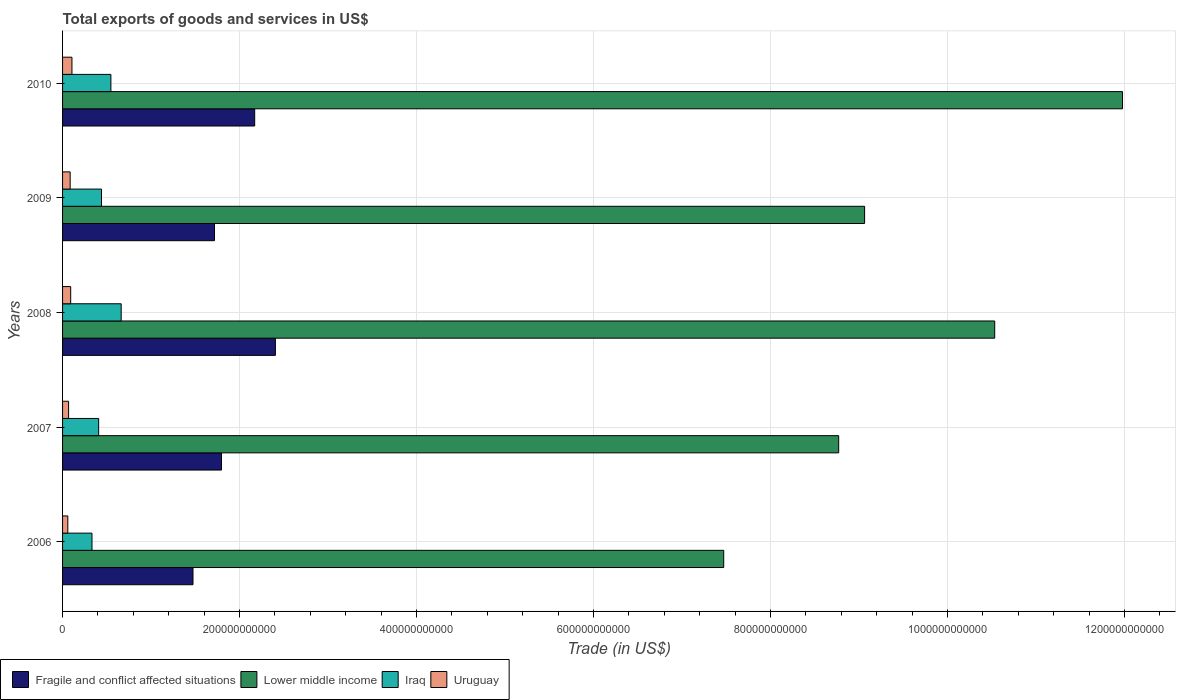How many bars are there on the 1st tick from the bottom?
Provide a short and direct response. 4. What is the label of the 4th group of bars from the top?
Give a very brief answer. 2007. What is the total exports of goods and services in Fragile and conflict affected situations in 2008?
Provide a short and direct response. 2.41e+11. Across all years, what is the maximum total exports of goods and services in Lower middle income?
Provide a short and direct response. 1.20e+12. Across all years, what is the minimum total exports of goods and services in Lower middle income?
Provide a short and direct response. 7.47e+11. In which year was the total exports of goods and services in Iraq maximum?
Offer a very short reply. 2008. What is the total total exports of goods and services in Lower middle income in the graph?
Give a very brief answer. 4.78e+12. What is the difference between the total exports of goods and services in Lower middle income in 2008 and that in 2009?
Offer a very short reply. 1.47e+11. What is the difference between the total exports of goods and services in Fragile and conflict affected situations in 2006 and the total exports of goods and services in Uruguay in 2008?
Provide a short and direct response. 1.38e+11. What is the average total exports of goods and services in Fragile and conflict affected situations per year?
Provide a short and direct response. 1.91e+11. In the year 2009, what is the difference between the total exports of goods and services in Lower middle income and total exports of goods and services in Uruguay?
Make the answer very short. 8.98e+11. In how many years, is the total exports of goods and services in Fragile and conflict affected situations greater than 400000000000 US$?
Provide a succinct answer. 0. What is the ratio of the total exports of goods and services in Lower middle income in 2008 to that in 2009?
Keep it short and to the point. 1.16. Is the total exports of goods and services in Lower middle income in 2008 less than that in 2010?
Your answer should be compact. Yes. What is the difference between the highest and the second highest total exports of goods and services in Lower middle income?
Ensure brevity in your answer.  1.44e+11. What is the difference between the highest and the lowest total exports of goods and services in Iraq?
Give a very brief answer. 3.30e+1. In how many years, is the total exports of goods and services in Uruguay greater than the average total exports of goods and services in Uruguay taken over all years?
Provide a succinct answer. 3. Is it the case that in every year, the sum of the total exports of goods and services in Iraq and total exports of goods and services in Uruguay is greater than the sum of total exports of goods and services in Lower middle income and total exports of goods and services in Fragile and conflict affected situations?
Offer a terse response. Yes. What does the 3rd bar from the top in 2008 represents?
Give a very brief answer. Lower middle income. What does the 1st bar from the bottom in 2008 represents?
Offer a very short reply. Fragile and conflict affected situations. Is it the case that in every year, the sum of the total exports of goods and services in Iraq and total exports of goods and services in Lower middle income is greater than the total exports of goods and services in Uruguay?
Offer a terse response. Yes. How many bars are there?
Give a very brief answer. 20. How many years are there in the graph?
Keep it short and to the point. 5. What is the difference between two consecutive major ticks on the X-axis?
Your answer should be very brief. 2.00e+11. Are the values on the major ticks of X-axis written in scientific E-notation?
Your answer should be compact. No. Does the graph contain any zero values?
Make the answer very short. No. Does the graph contain grids?
Make the answer very short. Yes. How many legend labels are there?
Your answer should be very brief. 4. What is the title of the graph?
Give a very brief answer. Total exports of goods and services in US$. Does "Mauritania" appear as one of the legend labels in the graph?
Your answer should be compact. No. What is the label or title of the X-axis?
Keep it short and to the point. Trade (in US$). What is the label or title of the Y-axis?
Your response must be concise. Years. What is the Trade (in US$) in Fragile and conflict affected situations in 2006?
Offer a terse response. 1.47e+11. What is the Trade (in US$) in Lower middle income in 2006?
Your response must be concise. 7.47e+11. What is the Trade (in US$) of Iraq in 2006?
Provide a succinct answer. 3.32e+1. What is the Trade (in US$) in Uruguay in 2006?
Offer a terse response. 5.93e+09. What is the Trade (in US$) of Fragile and conflict affected situations in 2007?
Make the answer very short. 1.80e+11. What is the Trade (in US$) in Lower middle income in 2007?
Offer a terse response. 8.77e+11. What is the Trade (in US$) of Iraq in 2007?
Your answer should be compact. 4.08e+1. What is the Trade (in US$) in Uruguay in 2007?
Your answer should be compact. 6.81e+09. What is the Trade (in US$) in Fragile and conflict affected situations in 2008?
Your answer should be compact. 2.41e+11. What is the Trade (in US$) of Lower middle income in 2008?
Make the answer very short. 1.05e+12. What is the Trade (in US$) in Iraq in 2008?
Your response must be concise. 6.62e+1. What is the Trade (in US$) in Uruguay in 2008?
Make the answer very short. 9.17e+09. What is the Trade (in US$) of Fragile and conflict affected situations in 2009?
Give a very brief answer. 1.72e+11. What is the Trade (in US$) in Lower middle income in 2009?
Offer a very short reply. 9.06e+11. What is the Trade (in US$) in Iraq in 2009?
Make the answer very short. 4.40e+1. What is the Trade (in US$) in Uruguay in 2009?
Offer a very short reply. 8.58e+09. What is the Trade (in US$) in Fragile and conflict affected situations in 2010?
Offer a terse response. 2.17e+11. What is the Trade (in US$) in Lower middle income in 2010?
Give a very brief answer. 1.20e+12. What is the Trade (in US$) of Iraq in 2010?
Provide a short and direct response. 5.46e+1. What is the Trade (in US$) of Uruguay in 2010?
Keep it short and to the point. 1.06e+1. Across all years, what is the maximum Trade (in US$) in Fragile and conflict affected situations?
Your answer should be very brief. 2.41e+11. Across all years, what is the maximum Trade (in US$) in Lower middle income?
Provide a succinct answer. 1.20e+12. Across all years, what is the maximum Trade (in US$) in Iraq?
Make the answer very short. 6.62e+1. Across all years, what is the maximum Trade (in US$) in Uruguay?
Ensure brevity in your answer.  1.06e+1. Across all years, what is the minimum Trade (in US$) in Fragile and conflict affected situations?
Offer a terse response. 1.47e+11. Across all years, what is the minimum Trade (in US$) in Lower middle income?
Give a very brief answer. 7.47e+11. Across all years, what is the minimum Trade (in US$) in Iraq?
Your answer should be compact. 3.32e+1. Across all years, what is the minimum Trade (in US$) in Uruguay?
Offer a terse response. 5.93e+09. What is the total Trade (in US$) in Fragile and conflict affected situations in the graph?
Make the answer very short. 9.56e+11. What is the total Trade (in US$) of Lower middle income in the graph?
Make the answer very short. 4.78e+12. What is the total Trade (in US$) in Iraq in the graph?
Provide a short and direct response. 2.39e+11. What is the total Trade (in US$) of Uruguay in the graph?
Offer a terse response. 4.11e+1. What is the difference between the Trade (in US$) of Fragile and conflict affected situations in 2006 and that in 2007?
Your answer should be compact. -3.22e+1. What is the difference between the Trade (in US$) of Lower middle income in 2006 and that in 2007?
Offer a very short reply. -1.30e+11. What is the difference between the Trade (in US$) in Iraq in 2006 and that in 2007?
Offer a terse response. -7.54e+09. What is the difference between the Trade (in US$) in Uruguay in 2006 and that in 2007?
Offer a very short reply. -8.78e+08. What is the difference between the Trade (in US$) of Fragile and conflict affected situations in 2006 and that in 2008?
Your response must be concise. -9.31e+1. What is the difference between the Trade (in US$) in Lower middle income in 2006 and that in 2008?
Your answer should be very brief. -3.06e+11. What is the difference between the Trade (in US$) in Iraq in 2006 and that in 2008?
Your response must be concise. -3.30e+1. What is the difference between the Trade (in US$) of Uruguay in 2006 and that in 2008?
Ensure brevity in your answer.  -3.24e+09. What is the difference between the Trade (in US$) of Fragile and conflict affected situations in 2006 and that in 2009?
Your response must be concise. -2.43e+1. What is the difference between the Trade (in US$) of Lower middle income in 2006 and that in 2009?
Keep it short and to the point. -1.59e+11. What is the difference between the Trade (in US$) of Iraq in 2006 and that in 2009?
Give a very brief answer. -1.08e+1. What is the difference between the Trade (in US$) in Uruguay in 2006 and that in 2009?
Ensure brevity in your answer.  -2.65e+09. What is the difference between the Trade (in US$) in Fragile and conflict affected situations in 2006 and that in 2010?
Provide a short and direct response. -6.97e+1. What is the difference between the Trade (in US$) in Lower middle income in 2006 and that in 2010?
Provide a succinct answer. -4.51e+11. What is the difference between the Trade (in US$) of Iraq in 2006 and that in 2010?
Offer a very short reply. -2.14e+1. What is the difference between the Trade (in US$) of Uruguay in 2006 and that in 2010?
Offer a very short reply. -4.68e+09. What is the difference between the Trade (in US$) of Fragile and conflict affected situations in 2007 and that in 2008?
Offer a terse response. -6.09e+1. What is the difference between the Trade (in US$) in Lower middle income in 2007 and that in 2008?
Offer a very short reply. -1.76e+11. What is the difference between the Trade (in US$) in Iraq in 2007 and that in 2008?
Give a very brief answer. -2.55e+1. What is the difference between the Trade (in US$) of Uruguay in 2007 and that in 2008?
Keep it short and to the point. -2.36e+09. What is the difference between the Trade (in US$) of Fragile and conflict affected situations in 2007 and that in 2009?
Offer a terse response. 7.91e+09. What is the difference between the Trade (in US$) of Lower middle income in 2007 and that in 2009?
Ensure brevity in your answer.  -2.93e+1. What is the difference between the Trade (in US$) of Iraq in 2007 and that in 2009?
Offer a terse response. -3.22e+09. What is the difference between the Trade (in US$) of Uruguay in 2007 and that in 2009?
Offer a terse response. -1.77e+09. What is the difference between the Trade (in US$) of Fragile and conflict affected situations in 2007 and that in 2010?
Give a very brief answer. -3.75e+1. What is the difference between the Trade (in US$) of Lower middle income in 2007 and that in 2010?
Give a very brief answer. -3.21e+11. What is the difference between the Trade (in US$) in Iraq in 2007 and that in 2010?
Offer a very short reply. -1.38e+1. What is the difference between the Trade (in US$) of Uruguay in 2007 and that in 2010?
Give a very brief answer. -3.80e+09. What is the difference between the Trade (in US$) in Fragile and conflict affected situations in 2008 and that in 2009?
Provide a succinct answer. 6.88e+1. What is the difference between the Trade (in US$) of Lower middle income in 2008 and that in 2009?
Offer a very short reply. 1.47e+11. What is the difference between the Trade (in US$) in Iraq in 2008 and that in 2009?
Provide a succinct answer. 2.22e+1. What is the difference between the Trade (in US$) of Uruguay in 2008 and that in 2009?
Keep it short and to the point. 5.92e+08. What is the difference between the Trade (in US$) in Fragile and conflict affected situations in 2008 and that in 2010?
Ensure brevity in your answer.  2.34e+1. What is the difference between the Trade (in US$) in Lower middle income in 2008 and that in 2010?
Your answer should be compact. -1.44e+11. What is the difference between the Trade (in US$) in Iraq in 2008 and that in 2010?
Your answer should be compact. 1.16e+1. What is the difference between the Trade (in US$) of Uruguay in 2008 and that in 2010?
Offer a terse response. -1.44e+09. What is the difference between the Trade (in US$) in Fragile and conflict affected situations in 2009 and that in 2010?
Offer a terse response. -4.54e+1. What is the difference between the Trade (in US$) of Lower middle income in 2009 and that in 2010?
Ensure brevity in your answer.  -2.91e+11. What is the difference between the Trade (in US$) of Iraq in 2009 and that in 2010?
Make the answer very short. -1.06e+1. What is the difference between the Trade (in US$) in Uruguay in 2009 and that in 2010?
Your response must be concise. -2.03e+09. What is the difference between the Trade (in US$) in Fragile and conflict affected situations in 2006 and the Trade (in US$) in Lower middle income in 2007?
Provide a succinct answer. -7.30e+11. What is the difference between the Trade (in US$) of Fragile and conflict affected situations in 2006 and the Trade (in US$) of Iraq in 2007?
Provide a short and direct response. 1.07e+11. What is the difference between the Trade (in US$) of Fragile and conflict affected situations in 2006 and the Trade (in US$) of Uruguay in 2007?
Provide a succinct answer. 1.41e+11. What is the difference between the Trade (in US$) of Lower middle income in 2006 and the Trade (in US$) of Iraq in 2007?
Your response must be concise. 7.06e+11. What is the difference between the Trade (in US$) in Lower middle income in 2006 and the Trade (in US$) in Uruguay in 2007?
Provide a short and direct response. 7.40e+11. What is the difference between the Trade (in US$) in Iraq in 2006 and the Trade (in US$) in Uruguay in 2007?
Give a very brief answer. 2.64e+1. What is the difference between the Trade (in US$) in Fragile and conflict affected situations in 2006 and the Trade (in US$) in Lower middle income in 2008?
Your answer should be very brief. -9.06e+11. What is the difference between the Trade (in US$) in Fragile and conflict affected situations in 2006 and the Trade (in US$) in Iraq in 2008?
Your response must be concise. 8.11e+1. What is the difference between the Trade (in US$) of Fragile and conflict affected situations in 2006 and the Trade (in US$) of Uruguay in 2008?
Offer a very short reply. 1.38e+11. What is the difference between the Trade (in US$) of Lower middle income in 2006 and the Trade (in US$) of Iraq in 2008?
Make the answer very short. 6.81e+11. What is the difference between the Trade (in US$) in Lower middle income in 2006 and the Trade (in US$) in Uruguay in 2008?
Provide a succinct answer. 7.38e+11. What is the difference between the Trade (in US$) of Iraq in 2006 and the Trade (in US$) of Uruguay in 2008?
Offer a very short reply. 2.41e+1. What is the difference between the Trade (in US$) of Fragile and conflict affected situations in 2006 and the Trade (in US$) of Lower middle income in 2009?
Keep it short and to the point. -7.59e+11. What is the difference between the Trade (in US$) in Fragile and conflict affected situations in 2006 and the Trade (in US$) in Iraq in 2009?
Offer a terse response. 1.03e+11. What is the difference between the Trade (in US$) in Fragile and conflict affected situations in 2006 and the Trade (in US$) in Uruguay in 2009?
Ensure brevity in your answer.  1.39e+11. What is the difference between the Trade (in US$) in Lower middle income in 2006 and the Trade (in US$) in Iraq in 2009?
Keep it short and to the point. 7.03e+11. What is the difference between the Trade (in US$) in Lower middle income in 2006 and the Trade (in US$) in Uruguay in 2009?
Keep it short and to the point. 7.39e+11. What is the difference between the Trade (in US$) of Iraq in 2006 and the Trade (in US$) of Uruguay in 2009?
Keep it short and to the point. 2.47e+1. What is the difference between the Trade (in US$) of Fragile and conflict affected situations in 2006 and the Trade (in US$) of Lower middle income in 2010?
Offer a very short reply. -1.05e+12. What is the difference between the Trade (in US$) in Fragile and conflict affected situations in 2006 and the Trade (in US$) in Iraq in 2010?
Your answer should be very brief. 9.28e+1. What is the difference between the Trade (in US$) of Fragile and conflict affected situations in 2006 and the Trade (in US$) of Uruguay in 2010?
Keep it short and to the point. 1.37e+11. What is the difference between the Trade (in US$) of Lower middle income in 2006 and the Trade (in US$) of Iraq in 2010?
Provide a succinct answer. 6.92e+11. What is the difference between the Trade (in US$) of Lower middle income in 2006 and the Trade (in US$) of Uruguay in 2010?
Ensure brevity in your answer.  7.36e+11. What is the difference between the Trade (in US$) in Iraq in 2006 and the Trade (in US$) in Uruguay in 2010?
Make the answer very short. 2.26e+1. What is the difference between the Trade (in US$) in Fragile and conflict affected situations in 2007 and the Trade (in US$) in Lower middle income in 2008?
Keep it short and to the point. -8.74e+11. What is the difference between the Trade (in US$) in Fragile and conflict affected situations in 2007 and the Trade (in US$) in Iraq in 2008?
Make the answer very short. 1.13e+11. What is the difference between the Trade (in US$) of Fragile and conflict affected situations in 2007 and the Trade (in US$) of Uruguay in 2008?
Make the answer very short. 1.70e+11. What is the difference between the Trade (in US$) of Lower middle income in 2007 and the Trade (in US$) of Iraq in 2008?
Your answer should be compact. 8.11e+11. What is the difference between the Trade (in US$) of Lower middle income in 2007 and the Trade (in US$) of Uruguay in 2008?
Offer a very short reply. 8.68e+11. What is the difference between the Trade (in US$) in Iraq in 2007 and the Trade (in US$) in Uruguay in 2008?
Provide a succinct answer. 3.16e+1. What is the difference between the Trade (in US$) in Fragile and conflict affected situations in 2007 and the Trade (in US$) in Lower middle income in 2009?
Your response must be concise. -7.27e+11. What is the difference between the Trade (in US$) in Fragile and conflict affected situations in 2007 and the Trade (in US$) in Iraq in 2009?
Offer a terse response. 1.36e+11. What is the difference between the Trade (in US$) of Fragile and conflict affected situations in 2007 and the Trade (in US$) of Uruguay in 2009?
Ensure brevity in your answer.  1.71e+11. What is the difference between the Trade (in US$) of Lower middle income in 2007 and the Trade (in US$) of Iraq in 2009?
Make the answer very short. 8.33e+11. What is the difference between the Trade (in US$) of Lower middle income in 2007 and the Trade (in US$) of Uruguay in 2009?
Give a very brief answer. 8.68e+11. What is the difference between the Trade (in US$) in Iraq in 2007 and the Trade (in US$) in Uruguay in 2009?
Keep it short and to the point. 3.22e+1. What is the difference between the Trade (in US$) of Fragile and conflict affected situations in 2007 and the Trade (in US$) of Lower middle income in 2010?
Make the answer very short. -1.02e+12. What is the difference between the Trade (in US$) of Fragile and conflict affected situations in 2007 and the Trade (in US$) of Iraq in 2010?
Your answer should be compact. 1.25e+11. What is the difference between the Trade (in US$) in Fragile and conflict affected situations in 2007 and the Trade (in US$) in Uruguay in 2010?
Your response must be concise. 1.69e+11. What is the difference between the Trade (in US$) of Lower middle income in 2007 and the Trade (in US$) of Iraq in 2010?
Your answer should be very brief. 8.22e+11. What is the difference between the Trade (in US$) of Lower middle income in 2007 and the Trade (in US$) of Uruguay in 2010?
Your answer should be compact. 8.66e+11. What is the difference between the Trade (in US$) in Iraq in 2007 and the Trade (in US$) in Uruguay in 2010?
Ensure brevity in your answer.  3.02e+1. What is the difference between the Trade (in US$) of Fragile and conflict affected situations in 2008 and the Trade (in US$) of Lower middle income in 2009?
Provide a succinct answer. -6.66e+11. What is the difference between the Trade (in US$) in Fragile and conflict affected situations in 2008 and the Trade (in US$) in Iraq in 2009?
Provide a short and direct response. 1.97e+11. What is the difference between the Trade (in US$) in Fragile and conflict affected situations in 2008 and the Trade (in US$) in Uruguay in 2009?
Ensure brevity in your answer.  2.32e+11. What is the difference between the Trade (in US$) of Lower middle income in 2008 and the Trade (in US$) of Iraq in 2009?
Make the answer very short. 1.01e+12. What is the difference between the Trade (in US$) in Lower middle income in 2008 and the Trade (in US$) in Uruguay in 2009?
Offer a terse response. 1.04e+12. What is the difference between the Trade (in US$) in Iraq in 2008 and the Trade (in US$) in Uruguay in 2009?
Keep it short and to the point. 5.77e+1. What is the difference between the Trade (in US$) of Fragile and conflict affected situations in 2008 and the Trade (in US$) of Lower middle income in 2010?
Your response must be concise. -9.57e+11. What is the difference between the Trade (in US$) of Fragile and conflict affected situations in 2008 and the Trade (in US$) of Iraq in 2010?
Keep it short and to the point. 1.86e+11. What is the difference between the Trade (in US$) in Fragile and conflict affected situations in 2008 and the Trade (in US$) in Uruguay in 2010?
Your answer should be compact. 2.30e+11. What is the difference between the Trade (in US$) of Lower middle income in 2008 and the Trade (in US$) of Iraq in 2010?
Offer a terse response. 9.99e+11. What is the difference between the Trade (in US$) of Lower middle income in 2008 and the Trade (in US$) of Uruguay in 2010?
Offer a terse response. 1.04e+12. What is the difference between the Trade (in US$) in Iraq in 2008 and the Trade (in US$) in Uruguay in 2010?
Your answer should be compact. 5.56e+1. What is the difference between the Trade (in US$) in Fragile and conflict affected situations in 2009 and the Trade (in US$) in Lower middle income in 2010?
Your answer should be very brief. -1.03e+12. What is the difference between the Trade (in US$) in Fragile and conflict affected situations in 2009 and the Trade (in US$) in Iraq in 2010?
Your response must be concise. 1.17e+11. What is the difference between the Trade (in US$) in Fragile and conflict affected situations in 2009 and the Trade (in US$) in Uruguay in 2010?
Offer a terse response. 1.61e+11. What is the difference between the Trade (in US$) of Lower middle income in 2009 and the Trade (in US$) of Iraq in 2010?
Your response must be concise. 8.52e+11. What is the difference between the Trade (in US$) in Lower middle income in 2009 and the Trade (in US$) in Uruguay in 2010?
Your answer should be very brief. 8.96e+11. What is the difference between the Trade (in US$) of Iraq in 2009 and the Trade (in US$) of Uruguay in 2010?
Your answer should be very brief. 3.34e+1. What is the average Trade (in US$) of Fragile and conflict affected situations per year?
Keep it short and to the point. 1.91e+11. What is the average Trade (in US$) in Lower middle income per year?
Keep it short and to the point. 9.56e+11. What is the average Trade (in US$) of Iraq per year?
Make the answer very short. 4.78e+1. What is the average Trade (in US$) of Uruguay per year?
Keep it short and to the point. 8.22e+09. In the year 2006, what is the difference between the Trade (in US$) in Fragile and conflict affected situations and Trade (in US$) in Lower middle income?
Provide a succinct answer. -6.00e+11. In the year 2006, what is the difference between the Trade (in US$) of Fragile and conflict affected situations and Trade (in US$) of Iraq?
Offer a terse response. 1.14e+11. In the year 2006, what is the difference between the Trade (in US$) in Fragile and conflict affected situations and Trade (in US$) in Uruguay?
Your answer should be compact. 1.41e+11. In the year 2006, what is the difference between the Trade (in US$) in Lower middle income and Trade (in US$) in Iraq?
Your response must be concise. 7.14e+11. In the year 2006, what is the difference between the Trade (in US$) in Lower middle income and Trade (in US$) in Uruguay?
Give a very brief answer. 7.41e+11. In the year 2006, what is the difference between the Trade (in US$) in Iraq and Trade (in US$) in Uruguay?
Provide a succinct answer. 2.73e+1. In the year 2007, what is the difference between the Trade (in US$) of Fragile and conflict affected situations and Trade (in US$) of Lower middle income?
Offer a terse response. -6.97e+11. In the year 2007, what is the difference between the Trade (in US$) in Fragile and conflict affected situations and Trade (in US$) in Iraq?
Give a very brief answer. 1.39e+11. In the year 2007, what is the difference between the Trade (in US$) of Fragile and conflict affected situations and Trade (in US$) of Uruguay?
Your answer should be compact. 1.73e+11. In the year 2007, what is the difference between the Trade (in US$) of Lower middle income and Trade (in US$) of Iraq?
Offer a very short reply. 8.36e+11. In the year 2007, what is the difference between the Trade (in US$) of Lower middle income and Trade (in US$) of Uruguay?
Your answer should be very brief. 8.70e+11. In the year 2007, what is the difference between the Trade (in US$) of Iraq and Trade (in US$) of Uruguay?
Provide a succinct answer. 3.40e+1. In the year 2008, what is the difference between the Trade (in US$) in Fragile and conflict affected situations and Trade (in US$) in Lower middle income?
Your answer should be compact. -8.13e+11. In the year 2008, what is the difference between the Trade (in US$) of Fragile and conflict affected situations and Trade (in US$) of Iraq?
Give a very brief answer. 1.74e+11. In the year 2008, what is the difference between the Trade (in US$) of Fragile and conflict affected situations and Trade (in US$) of Uruguay?
Offer a very short reply. 2.31e+11. In the year 2008, what is the difference between the Trade (in US$) of Lower middle income and Trade (in US$) of Iraq?
Provide a short and direct response. 9.87e+11. In the year 2008, what is the difference between the Trade (in US$) of Lower middle income and Trade (in US$) of Uruguay?
Your answer should be compact. 1.04e+12. In the year 2008, what is the difference between the Trade (in US$) in Iraq and Trade (in US$) in Uruguay?
Give a very brief answer. 5.71e+1. In the year 2009, what is the difference between the Trade (in US$) in Fragile and conflict affected situations and Trade (in US$) in Lower middle income?
Make the answer very short. -7.35e+11. In the year 2009, what is the difference between the Trade (in US$) in Fragile and conflict affected situations and Trade (in US$) in Iraq?
Keep it short and to the point. 1.28e+11. In the year 2009, what is the difference between the Trade (in US$) of Fragile and conflict affected situations and Trade (in US$) of Uruguay?
Ensure brevity in your answer.  1.63e+11. In the year 2009, what is the difference between the Trade (in US$) of Lower middle income and Trade (in US$) of Iraq?
Offer a very short reply. 8.62e+11. In the year 2009, what is the difference between the Trade (in US$) of Lower middle income and Trade (in US$) of Uruguay?
Ensure brevity in your answer.  8.98e+11. In the year 2009, what is the difference between the Trade (in US$) in Iraq and Trade (in US$) in Uruguay?
Offer a very short reply. 3.54e+1. In the year 2010, what is the difference between the Trade (in US$) in Fragile and conflict affected situations and Trade (in US$) in Lower middle income?
Give a very brief answer. -9.81e+11. In the year 2010, what is the difference between the Trade (in US$) of Fragile and conflict affected situations and Trade (in US$) of Iraq?
Give a very brief answer. 1.62e+11. In the year 2010, what is the difference between the Trade (in US$) in Fragile and conflict affected situations and Trade (in US$) in Uruguay?
Keep it short and to the point. 2.06e+11. In the year 2010, what is the difference between the Trade (in US$) of Lower middle income and Trade (in US$) of Iraq?
Your answer should be compact. 1.14e+12. In the year 2010, what is the difference between the Trade (in US$) in Lower middle income and Trade (in US$) in Uruguay?
Make the answer very short. 1.19e+12. In the year 2010, what is the difference between the Trade (in US$) in Iraq and Trade (in US$) in Uruguay?
Your answer should be very brief. 4.40e+1. What is the ratio of the Trade (in US$) in Fragile and conflict affected situations in 2006 to that in 2007?
Provide a short and direct response. 0.82. What is the ratio of the Trade (in US$) of Lower middle income in 2006 to that in 2007?
Provide a short and direct response. 0.85. What is the ratio of the Trade (in US$) of Iraq in 2006 to that in 2007?
Give a very brief answer. 0.82. What is the ratio of the Trade (in US$) in Uruguay in 2006 to that in 2007?
Your answer should be compact. 0.87. What is the ratio of the Trade (in US$) in Fragile and conflict affected situations in 2006 to that in 2008?
Provide a short and direct response. 0.61. What is the ratio of the Trade (in US$) in Lower middle income in 2006 to that in 2008?
Your answer should be compact. 0.71. What is the ratio of the Trade (in US$) in Iraq in 2006 to that in 2008?
Keep it short and to the point. 0.5. What is the ratio of the Trade (in US$) in Uruguay in 2006 to that in 2008?
Your answer should be compact. 0.65. What is the ratio of the Trade (in US$) in Fragile and conflict affected situations in 2006 to that in 2009?
Keep it short and to the point. 0.86. What is the ratio of the Trade (in US$) in Lower middle income in 2006 to that in 2009?
Your answer should be very brief. 0.82. What is the ratio of the Trade (in US$) of Iraq in 2006 to that in 2009?
Offer a very short reply. 0.76. What is the ratio of the Trade (in US$) of Uruguay in 2006 to that in 2009?
Make the answer very short. 0.69. What is the ratio of the Trade (in US$) in Fragile and conflict affected situations in 2006 to that in 2010?
Your answer should be very brief. 0.68. What is the ratio of the Trade (in US$) of Lower middle income in 2006 to that in 2010?
Offer a terse response. 0.62. What is the ratio of the Trade (in US$) in Iraq in 2006 to that in 2010?
Give a very brief answer. 0.61. What is the ratio of the Trade (in US$) in Uruguay in 2006 to that in 2010?
Keep it short and to the point. 0.56. What is the ratio of the Trade (in US$) in Fragile and conflict affected situations in 2007 to that in 2008?
Ensure brevity in your answer.  0.75. What is the ratio of the Trade (in US$) of Lower middle income in 2007 to that in 2008?
Your answer should be very brief. 0.83. What is the ratio of the Trade (in US$) in Iraq in 2007 to that in 2008?
Ensure brevity in your answer.  0.62. What is the ratio of the Trade (in US$) of Uruguay in 2007 to that in 2008?
Your response must be concise. 0.74. What is the ratio of the Trade (in US$) of Fragile and conflict affected situations in 2007 to that in 2009?
Keep it short and to the point. 1.05. What is the ratio of the Trade (in US$) of Iraq in 2007 to that in 2009?
Your response must be concise. 0.93. What is the ratio of the Trade (in US$) in Uruguay in 2007 to that in 2009?
Provide a short and direct response. 0.79. What is the ratio of the Trade (in US$) of Fragile and conflict affected situations in 2007 to that in 2010?
Make the answer very short. 0.83. What is the ratio of the Trade (in US$) of Lower middle income in 2007 to that in 2010?
Your answer should be compact. 0.73. What is the ratio of the Trade (in US$) in Iraq in 2007 to that in 2010?
Ensure brevity in your answer.  0.75. What is the ratio of the Trade (in US$) in Uruguay in 2007 to that in 2010?
Keep it short and to the point. 0.64. What is the ratio of the Trade (in US$) in Fragile and conflict affected situations in 2008 to that in 2009?
Provide a short and direct response. 1.4. What is the ratio of the Trade (in US$) of Lower middle income in 2008 to that in 2009?
Ensure brevity in your answer.  1.16. What is the ratio of the Trade (in US$) in Iraq in 2008 to that in 2009?
Your answer should be compact. 1.51. What is the ratio of the Trade (in US$) in Uruguay in 2008 to that in 2009?
Your answer should be very brief. 1.07. What is the ratio of the Trade (in US$) of Fragile and conflict affected situations in 2008 to that in 2010?
Offer a very short reply. 1.11. What is the ratio of the Trade (in US$) in Lower middle income in 2008 to that in 2010?
Provide a short and direct response. 0.88. What is the ratio of the Trade (in US$) in Iraq in 2008 to that in 2010?
Offer a terse response. 1.21. What is the ratio of the Trade (in US$) of Uruguay in 2008 to that in 2010?
Your response must be concise. 0.86. What is the ratio of the Trade (in US$) of Fragile and conflict affected situations in 2009 to that in 2010?
Ensure brevity in your answer.  0.79. What is the ratio of the Trade (in US$) in Lower middle income in 2009 to that in 2010?
Your answer should be compact. 0.76. What is the ratio of the Trade (in US$) of Iraq in 2009 to that in 2010?
Your answer should be very brief. 0.81. What is the ratio of the Trade (in US$) of Uruguay in 2009 to that in 2010?
Your answer should be compact. 0.81. What is the difference between the highest and the second highest Trade (in US$) in Fragile and conflict affected situations?
Your answer should be compact. 2.34e+1. What is the difference between the highest and the second highest Trade (in US$) of Lower middle income?
Offer a terse response. 1.44e+11. What is the difference between the highest and the second highest Trade (in US$) in Iraq?
Your response must be concise. 1.16e+1. What is the difference between the highest and the second highest Trade (in US$) in Uruguay?
Ensure brevity in your answer.  1.44e+09. What is the difference between the highest and the lowest Trade (in US$) in Fragile and conflict affected situations?
Offer a terse response. 9.31e+1. What is the difference between the highest and the lowest Trade (in US$) in Lower middle income?
Offer a very short reply. 4.51e+11. What is the difference between the highest and the lowest Trade (in US$) in Iraq?
Offer a terse response. 3.30e+1. What is the difference between the highest and the lowest Trade (in US$) of Uruguay?
Provide a short and direct response. 4.68e+09. 